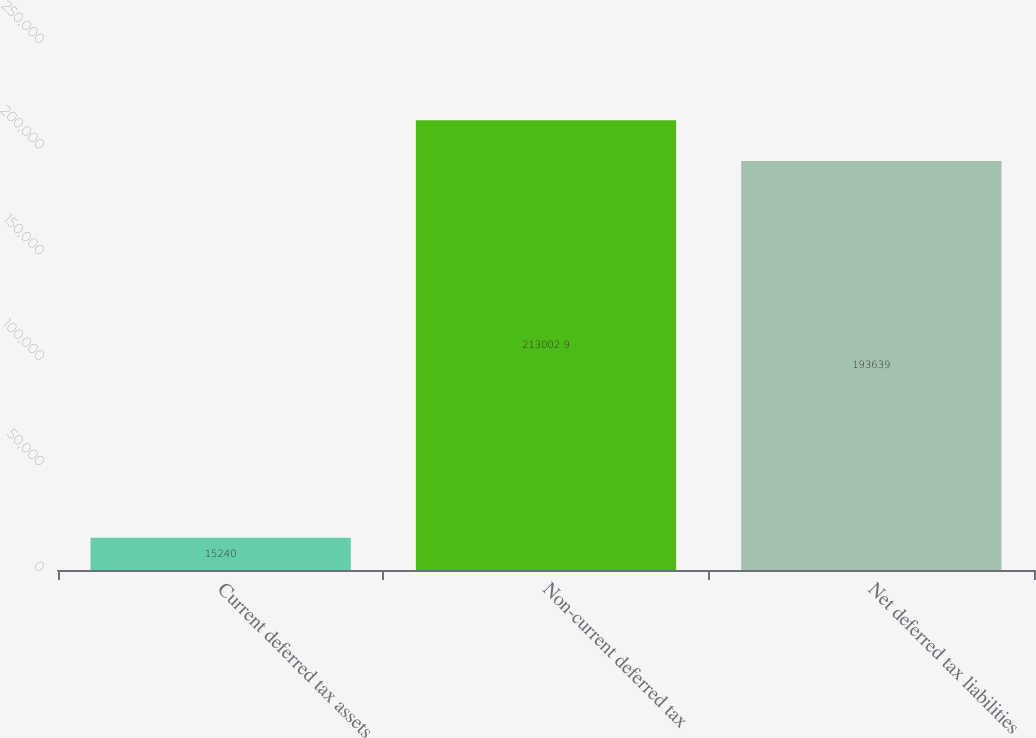Convert chart to OTSL. <chart><loc_0><loc_0><loc_500><loc_500><bar_chart><fcel>Current deferred tax assets<fcel>Non-current deferred tax<fcel>Net deferred tax liabilities<nl><fcel>15240<fcel>213003<fcel>193639<nl></chart> 